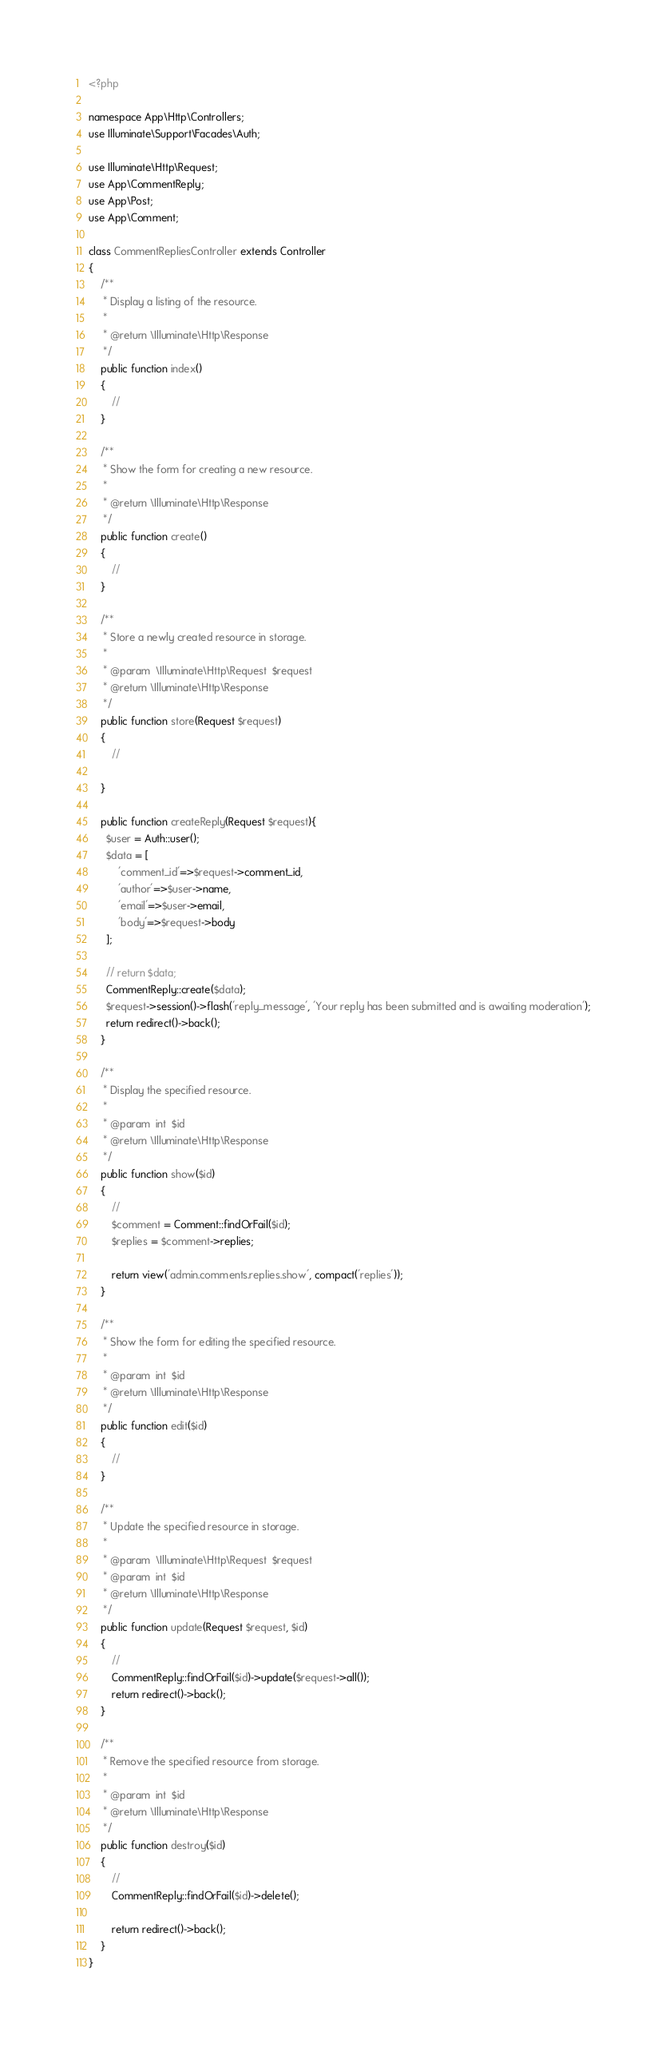Convert code to text. <code><loc_0><loc_0><loc_500><loc_500><_PHP_><?php

namespace App\Http\Controllers;
use Illuminate\Support\Facades\Auth;

use Illuminate\Http\Request;
use App\CommentReply;
use App\Post;
use App\Comment;

class CommentRepliesController extends Controller
{
    /**
     * Display a listing of the resource.
     *
     * @return \Illuminate\Http\Response
     */
    public function index()
    {
        //
    }

    /**
     * Show the form for creating a new resource.
     *
     * @return \Illuminate\Http\Response
     */
    public function create()
    {
        //
    }

    /**
     * Store a newly created resource in storage.
     *
     * @param  \Illuminate\Http\Request  $request
     * @return \Illuminate\Http\Response
     */
    public function store(Request $request)
    {
        //

    }

    public function createReply(Request $request){
      $user = Auth::user();
      $data = [
          'comment_id'=>$request->comment_id,
          'author'=>$user->name,
          'email'=>$user->email,
          'body'=>$request->body
      ];

      // return $data;
      CommentReply::create($data);
      $request->session()->flash('reply_message', 'Your reply has been submitted and is awaiting moderation');
      return redirect()->back();
    }

    /**
     * Display the specified resource.
     *
     * @param  int  $id
     * @return \Illuminate\Http\Response
     */
    public function show($id)
    {
        //
        $comment = Comment::findOrFail($id);
        $replies = $comment->replies;

        return view('admin.comments.replies.show', compact('replies'));
    }

    /**
     * Show the form for editing the specified resource.
     *
     * @param  int  $id
     * @return \Illuminate\Http\Response
     */
    public function edit($id)
    {
        //
    }

    /**
     * Update the specified resource in storage.
     *
     * @param  \Illuminate\Http\Request  $request
     * @param  int  $id
     * @return \Illuminate\Http\Response
     */
    public function update(Request $request, $id)
    {
        //
        CommentReply::findOrFail($id)->update($request->all());
        return redirect()->back();
    }

    /**
     * Remove the specified resource from storage.
     *
     * @param  int  $id
     * @return \Illuminate\Http\Response
     */
    public function destroy($id)
    {
        //
        CommentReply::findOrFail($id)->delete();

        return redirect()->back();
    }
}
</code> 